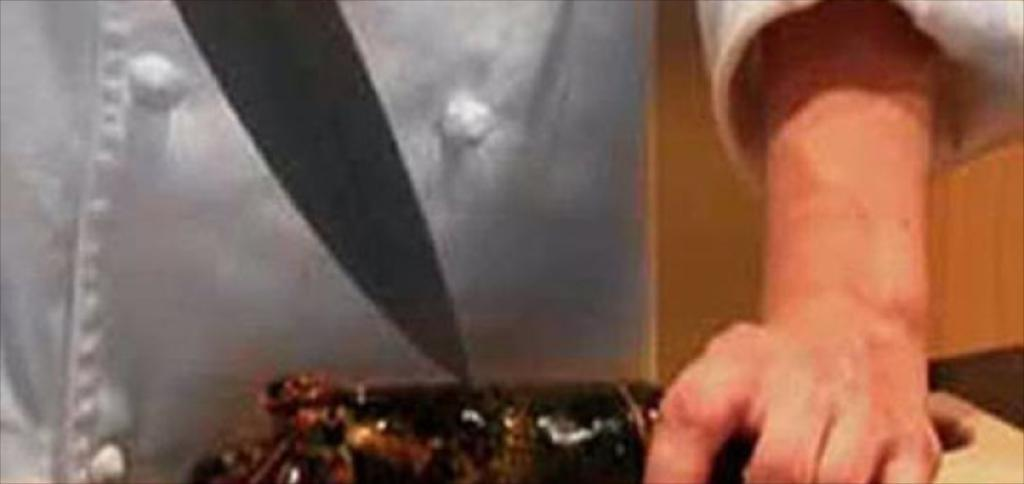Who is present in the image? There is a person in the image. What is the person holding in the image? The person is holding a fish. Where is the fish placed in the image? The fish is placed on a surface. What tool is visible in the image? There is a knife visible in the image. What type of eye makeup is the person wearing in the image? There is no mention of eye makeup or any other cosmetics in the image; the focus is on the person holding a fish and the presence of a knife. 